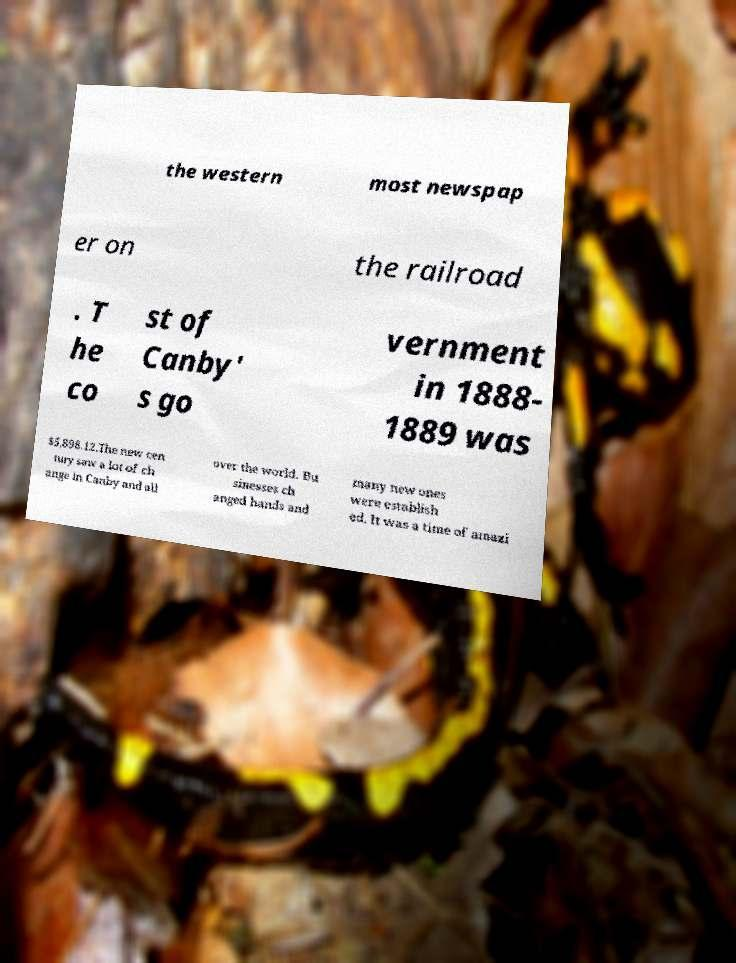Please identify and transcribe the text found in this image. the western most newspap er on the railroad . T he co st of Canby' s go vernment in 1888- 1889 was $5,898.12.The new cen tury saw a lot of ch ange in Canby and all over the world. Bu sinesses ch anged hands and many new ones were establish ed. It was a time of amazi 